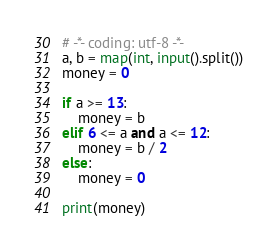<code> <loc_0><loc_0><loc_500><loc_500><_Python_># -*- coding: utf-8 -*-
a, b = map(int, input().split())
money = 0

if a >= 13:
    money = b
elif 6 <= a and a <= 12:
    money = b / 2
else:
    money = 0

print(money)</code> 